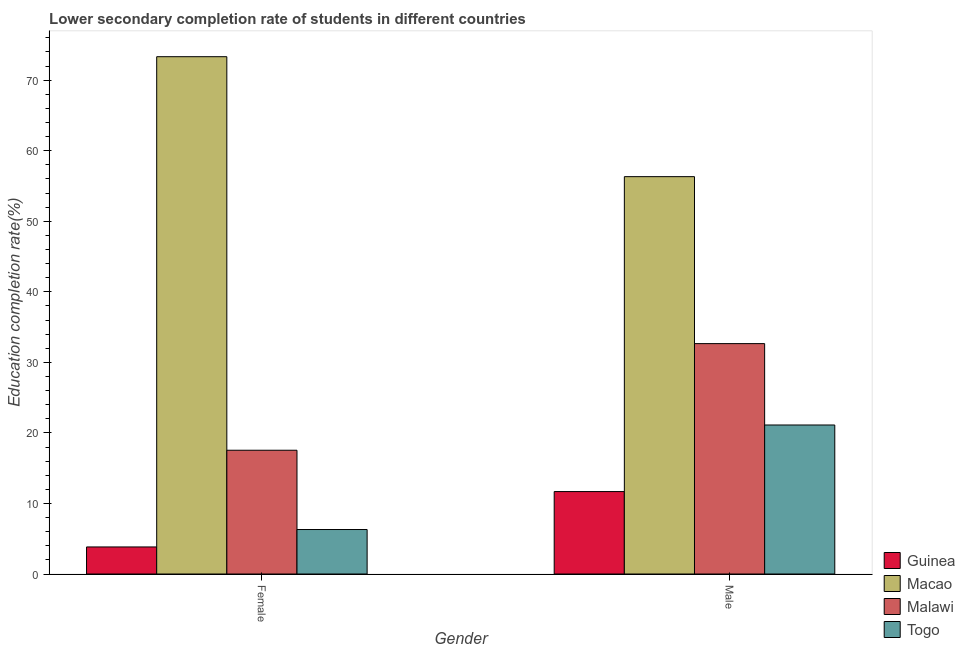How many different coloured bars are there?
Offer a very short reply. 4. How many groups of bars are there?
Keep it short and to the point. 2. How many bars are there on the 2nd tick from the right?
Offer a very short reply. 4. What is the education completion rate of female students in Malawi?
Your response must be concise. 17.54. Across all countries, what is the maximum education completion rate of female students?
Your response must be concise. 73.33. Across all countries, what is the minimum education completion rate of female students?
Your answer should be compact. 3.83. In which country was the education completion rate of female students maximum?
Offer a terse response. Macao. In which country was the education completion rate of female students minimum?
Offer a terse response. Guinea. What is the total education completion rate of male students in the graph?
Give a very brief answer. 121.79. What is the difference between the education completion rate of male students in Togo and that in Malawi?
Provide a succinct answer. -11.54. What is the difference between the education completion rate of female students in Macao and the education completion rate of male students in Malawi?
Your response must be concise. 40.67. What is the average education completion rate of female students per country?
Offer a very short reply. 25.25. What is the difference between the education completion rate of male students and education completion rate of female students in Macao?
Offer a terse response. -17. In how many countries, is the education completion rate of male students greater than 50 %?
Make the answer very short. 1. What is the ratio of the education completion rate of male students in Guinea to that in Malawi?
Your response must be concise. 0.36. Is the education completion rate of male students in Macao less than that in Togo?
Your answer should be compact. No. In how many countries, is the education completion rate of female students greater than the average education completion rate of female students taken over all countries?
Provide a short and direct response. 1. What does the 4th bar from the left in Female represents?
Provide a short and direct response. Togo. What does the 4th bar from the right in Female represents?
Your response must be concise. Guinea. How many bars are there?
Your response must be concise. 8. How many countries are there in the graph?
Provide a succinct answer. 4. What is the difference between two consecutive major ticks on the Y-axis?
Give a very brief answer. 10. Does the graph contain grids?
Your answer should be very brief. No. Where does the legend appear in the graph?
Your answer should be very brief. Bottom right. How are the legend labels stacked?
Make the answer very short. Vertical. What is the title of the graph?
Keep it short and to the point. Lower secondary completion rate of students in different countries. What is the label or title of the Y-axis?
Provide a succinct answer. Education completion rate(%). What is the Education completion rate(%) in Guinea in Female?
Ensure brevity in your answer.  3.83. What is the Education completion rate(%) of Macao in Female?
Your answer should be compact. 73.33. What is the Education completion rate(%) of Malawi in Female?
Your answer should be very brief. 17.54. What is the Education completion rate(%) of Togo in Female?
Provide a short and direct response. 6.31. What is the Education completion rate(%) in Guinea in Male?
Your response must be concise. 11.68. What is the Education completion rate(%) in Macao in Male?
Provide a succinct answer. 56.33. What is the Education completion rate(%) in Malawi in Male?
Provide a succinct answer. 32.66. What is the Education completion rate(%) in Togo in Male?
Provide a succinct answer. 21.12. Across all Gender, what is the maximum Education completion rate(%) in Guinea?
Provide a succinct answer. 11.68. Across all Gender, what is the maximum Education completion rate(%) in Macao?
Your answer should be very brief. 73.33. Across all Gender, what is the maximum Education completion rate(%) in Malawi?
Your response must be concise. 32.66. Across all Gender, what is the maximum Education completion rate(%) of Togo?
Your response must be concise. 21.12. Across all Gender, what is the minimum Education completion rate(%) of Guinea?
Your answer should be very brief. 3.83. Across all Gender, what is the minimum Education completion rate(%) in Macao?
Ensure brevity in your answer.  56.33. Across all Gender, what is the minimum Education completion rate(%) of Malawi?
Provide a succinct answer. 17.54. Across all Gender, what is the minimum Education completion rate(%) of Togo?
Give a very brief answer. 6.31. What is the total Education completion rate(%) in Guinea in the graph?
Keep it short and to the point. 15.52. What is the total Education completion rate(%) of Macao in the graph?
Your answer should be very brief. 129.66. What is the total Education completion rate(%) of Malawi in the graph?
Your response must be concise. 50.2. What is the total Education completion rate(%) in Togo in the graph?
Your answer should be very brief. 27.43. What is the difference between the Education completion rate(%) of Guinea in Female and that in Male?
Provide a short and direct response. -7.85. What is the difference between the Education completion rate(%) in Macao in Female and that in Male?
Offer a terse response. 17. What is the difference between the Education completion rate(%) in Malawi in Female and that in Male?
Your response must be concise. -15.12. What is the difference between the Education completion rate(%) in Togo in Female and that in Male?
Make the answer very short. -14.82. What is the difference between the Education completion rate(%) in Guinea in Female and the Education completion rate(%) in Macao in Male?
Give a very brief answer. -52.49. What is the difference between the Education completion rate(%) in Guinea in Female and the Education completion rate(%) in Malawi in Male?
Make the answer very short. -28.82. What is the difference between the Education completion rate(%) in Guinea in Female and the Education completion rate(%) in Togo in Male?
Your response must be concise. -17.29. What is the difference between the Education completion rate(%) in Macao in Female and the Education completion rate(%) in Malawi in Male?
Your response must be concise. 40.67. What is the difference between the Education completion rate(%) of Macao in Female and the Education completion rate(%) of Togo in Male?
Offer a very short reply. 52.21. What is the difference between the Education completion rate(%) of Malawi in Female and the Education completion rate(%) of Togo in Male?
Keep it short and to the point. -3.58. What is the average Education completion rate(%) of Guinea per Gender?
Your answer should be compact. 7.76. What is the average Education completion rate(%) of Macao per Gender?
Your response must be concise. 64.83. What is the average Education completion rate(%) of Malawi per Gender?
Your response must be concise. 25.1. What is the average Education completion rate(%) of Togo per Gender?
Make the answer very short. 13.71. What is the difference between the Education completion rate(%) in Guinea and Education completion rate(%) in Macao in Female?
Ensure brevity in your answer.  -69.5. What is the difference between the Education completion rate(%) of Guinea and Education completion rate(%) of Malawi in Female?
Your answer should be very brief. -13.71. What is the difference between the Education completion rate(%) in Guinea and Education completion rate(%) in Togo in Female?
Ensure brevity in your answer.  -2.47. What is the difference between the Education completion rate(%) in Macao and Education completion rate(%) in Malawi in Female?
Your answer should be very brief. 55.79. What is the difference between the Education completion rate(%) in Macao and Education completion rate(%) in Togo in Female?
Your response must be concise. 67.02. What is the difference between the Education completion rate(%) in Malawi and Education completion rate(%) in Togo in Female?
Your answer should be compact. 11.24. What is the difference between the Education completion rate(%) in Guinea and Education completion rate(%) in Macao in Male?
Your response must be concise. -44.64. What is the difference between the Education completion rate(%) of Guinea and Education completion rate(%) of Malawi in Male?
Provide a succinct answer. -20.97. What is the difference between the Education completion rate(%) in Guinea and Education completion rate(%) in Togo in Male?
Keep it short and to the point. -9.44. What is the difference between the Education completion rate(%) in Macao and Education completion rate(%) in Malawi in Male?
Provide a succinct answer. 23.67. What is the difference between the Education completion rate(%) of Macao and Education completion rate(%) of Togo in Male?
Make the answer very short. 35.2. What is the difference between the Education completion rate(%) in Malawi and Education completion rate(%) in Togo in Male?
Provide a short and direct response. 11.54. What is the ratio of the Education completion rate(%) of Guinea in Female to that in Male?
Keep it short and to the point. 0.33. What is the ratio of the Education completion rate(%) in Macao in Female to that in Male?
Your response must be concise. 1.3. What is the ratio of the Education completion rate(%) in Malawi in Female to that in Male?
Keep it short and to the point. 0.54. What is the ratio of the Education completion rate(%) of Togo in Female to that in Male?
Give a very brief answer. 0.3. What is the difference between the highest and the second highest Education completion rate(%) of Guinea?
Your response must be concise. 7.85. What is the difference between the highest and the second highest Education completion rate(%) of Macao?
Your answer should be very brief. 17. What is the difference between the highest and the second highest Education completion rate(%) of Malawi?
Your answer should be very brief. 15.12. What is the difference between the highest and the second highest Education completion rate(%) in Togo?
Provide a short and direct response. 14.82. What is the difference between the highest and the lowest Education completion rate(%) of Guinea?
Ensure brevity in your answer.  7.85. What is the difference between the highest and the lowest Education completion rate(%) in Macao?
Offer a terse response. 17. What is the difference between the highest and the lowest Education completion rate(%) of Malawi?
Your answer should be compact. 15.12. What is the difference between the highest and the lowest Education completion rate(%) in Togo?
Make the answer very short. 14.82. 